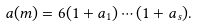<formula> <loc_0><loc_0><loc_500><loc_500>a ( m ) = 6 ( 1 + a _ { 1 } ) \cdots ( 1 + a _ { s } ) .</formula> 